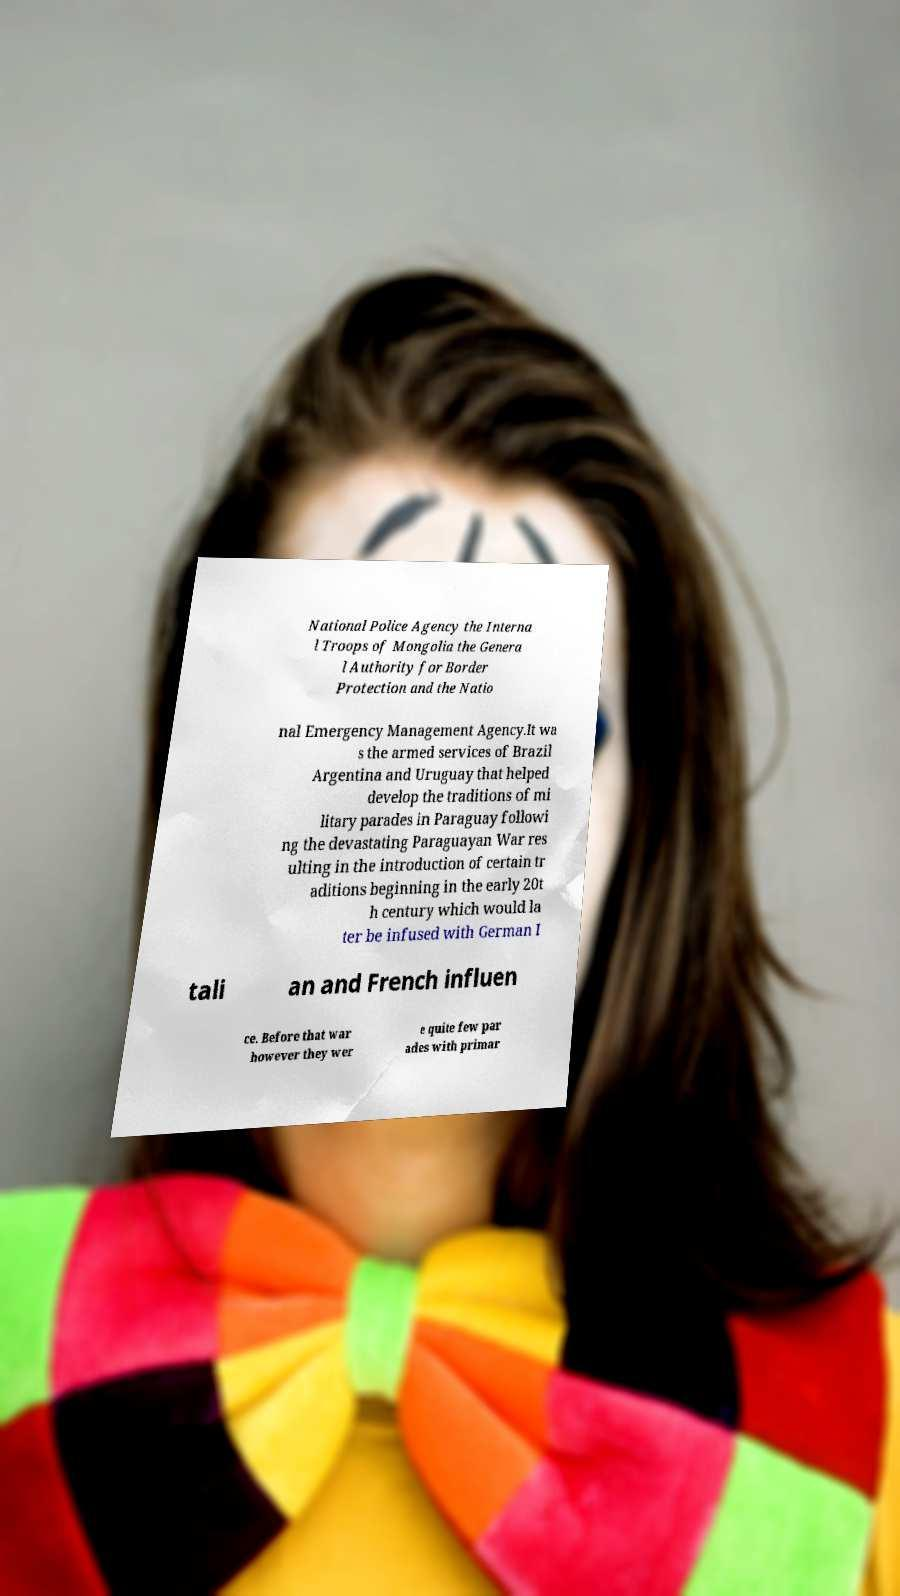I need the written content from this picture converted into text. Can you do that? National Police Agency the Interna l Troops of Mongolia the Genera l Authority for Border Protection and the Natio nal Emergency Management Agency.It wa s the armed services of Brazil Argentina and Uruguay that helped develop the traditions of mi litary parades in Paraguay followi ng the devastating Paraguayan War res ulting in the introduction of certain tr aditions beginning in the early 20t h century which would la ter be infused with German I tali an and French influen ce. Before that war however they wer e quite few par ades with primar 